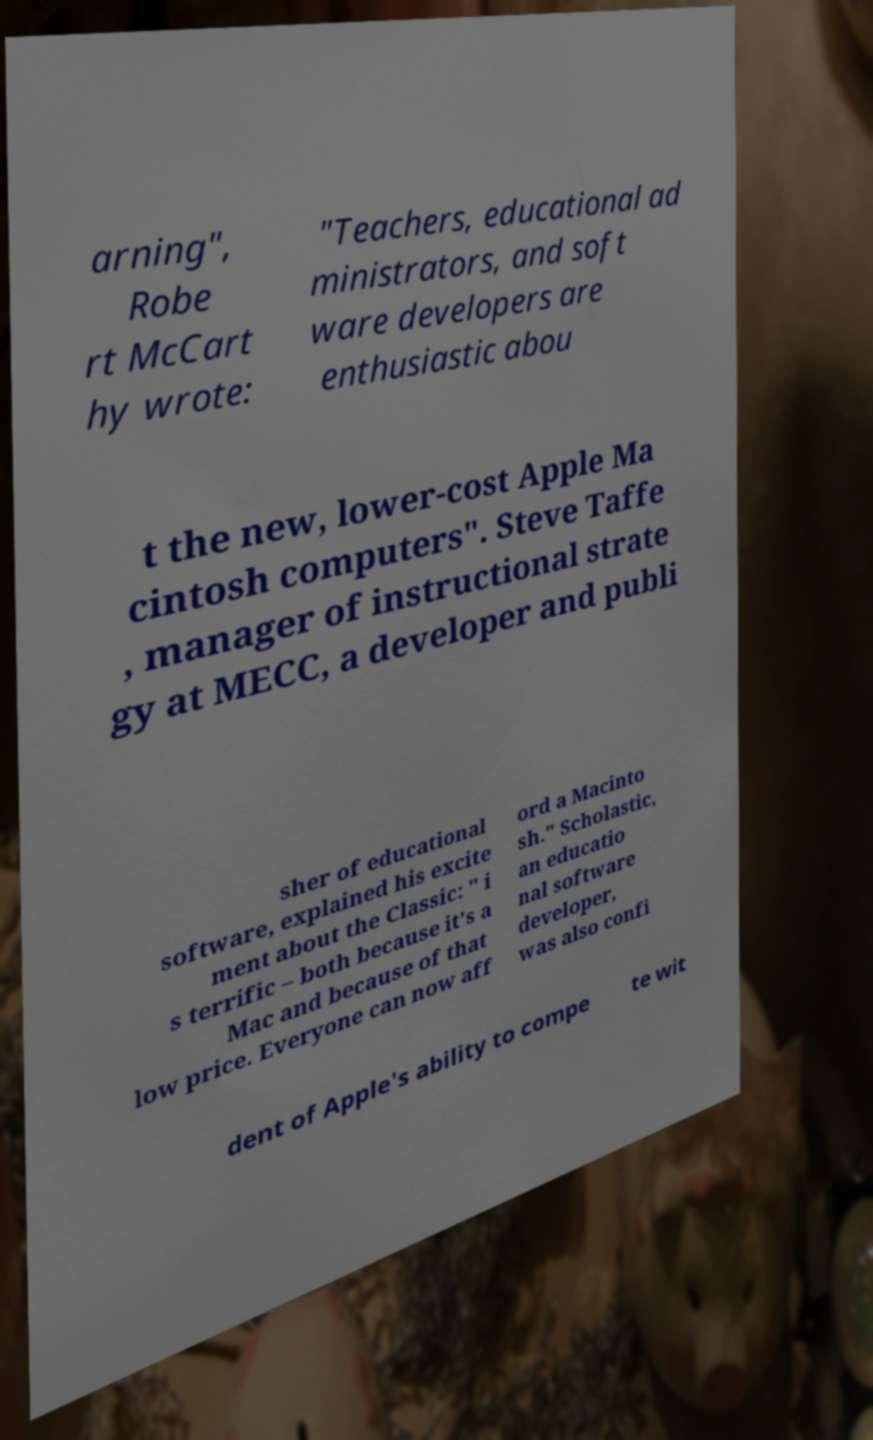I need the written content from this picture converted into text. Can you do that? arning", Robe rt McCart hy wrote: "Teachers, educational ad ministrators, and soft ware developers are enthusiastic abou t the new, lower-cost Apple Ma cintosh computers". Steve Taffe , manager of instructional strate gy at MECC, a developer and publi sher of educational software, explained his excite ment about the Classic: " i s terrific – both because it's a Mac and because of that low price. Everyone can now aff ord a Macinto sh." Scholastic, an educatio nal software developer, was also confi dent of Apple's ability to compe te wit 